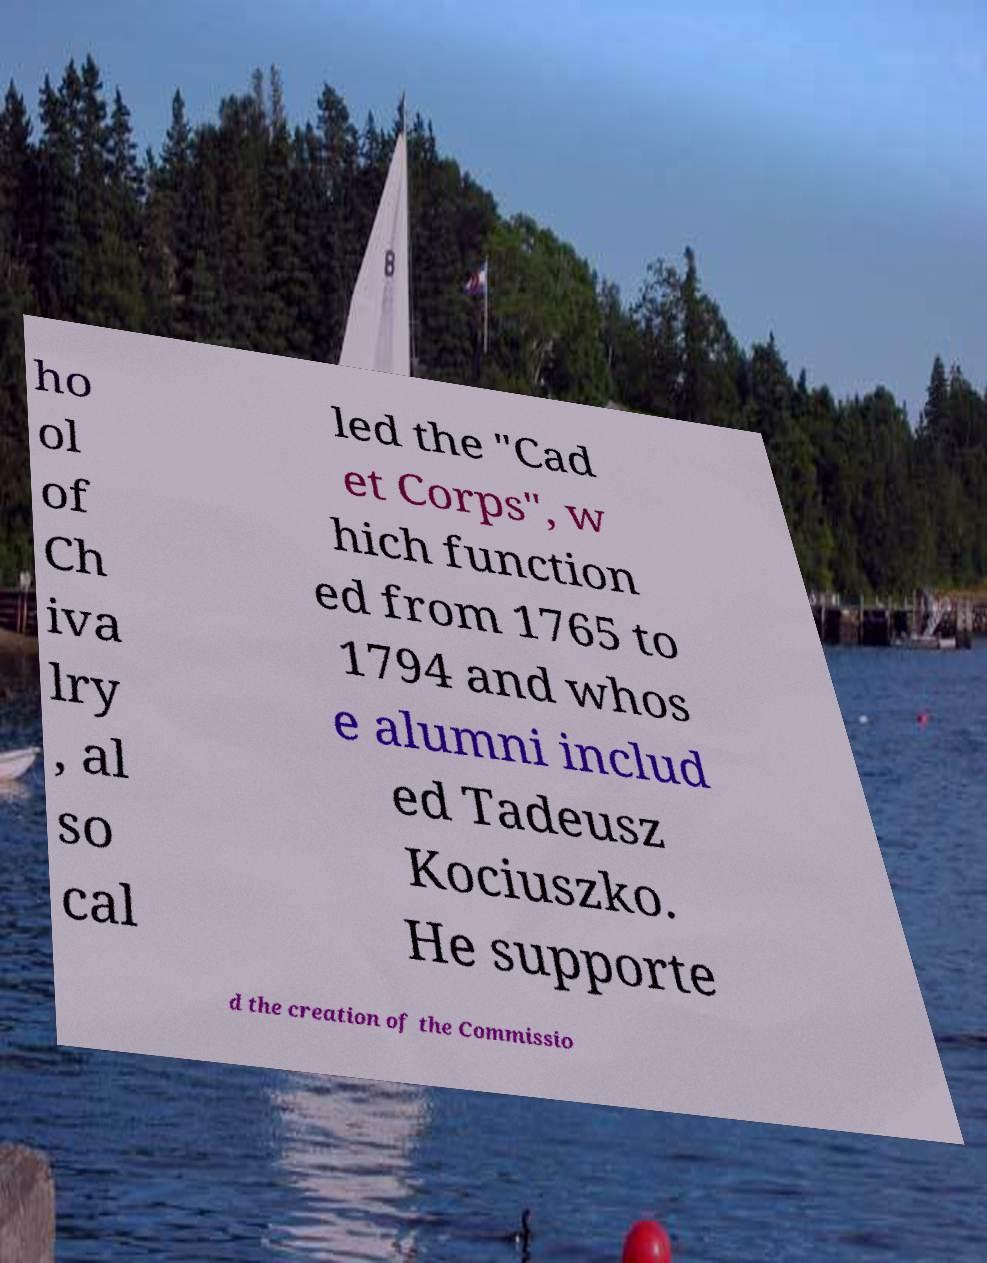What messages or text are displayed in this image? I need them in a readable, typed format. ho ol of Ch iva lry , al so cal led the "Cad et Corps", w hich function ed from 1765 to 1794 and whos e alumni includ ed Tadeusz Kociuszko. He supporte d the creation of the Commissio 